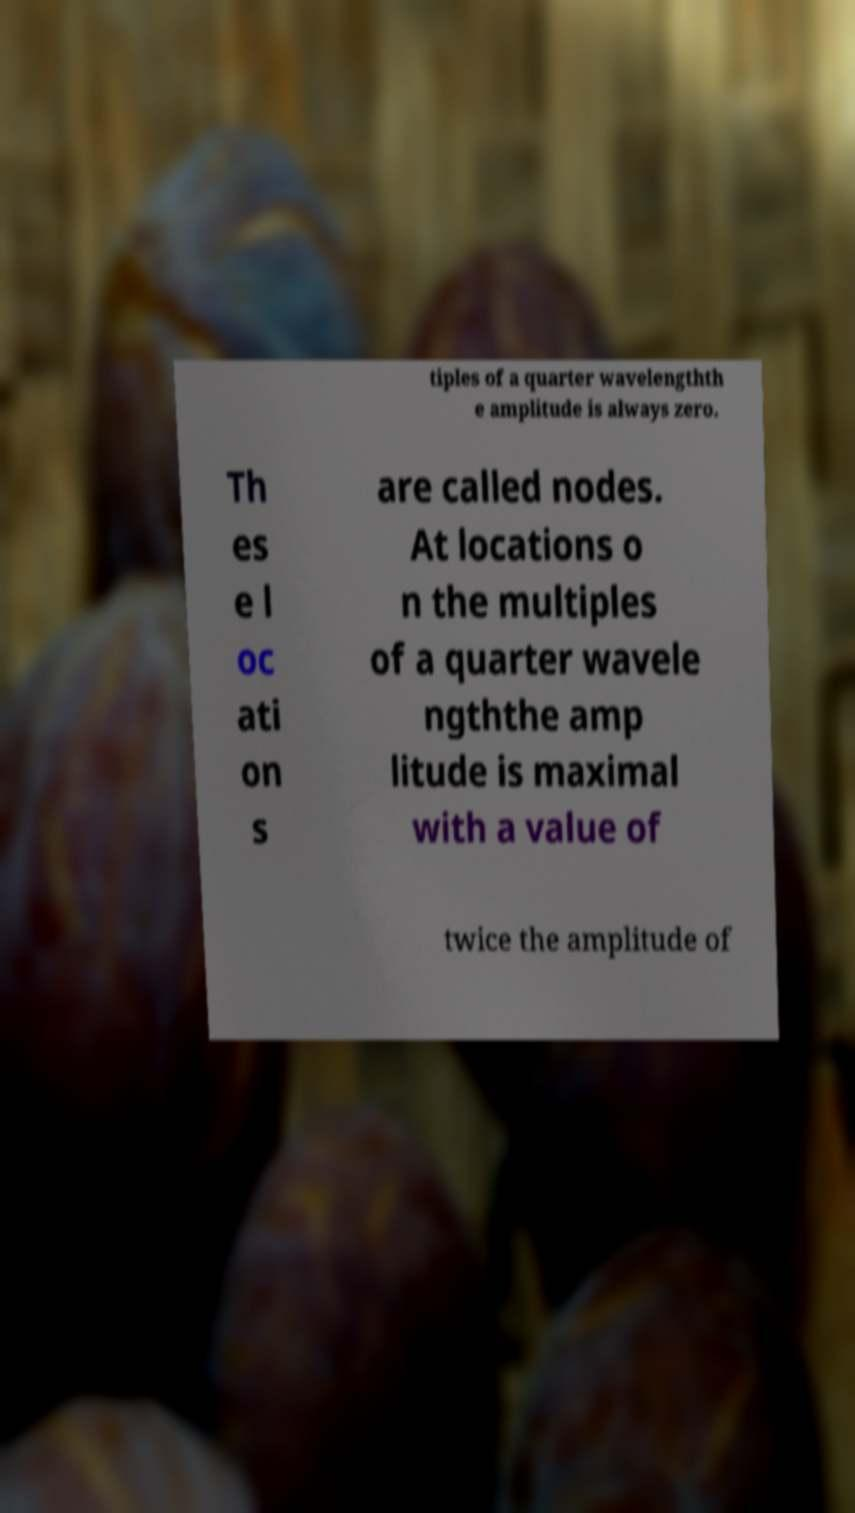What messages or text are displayed in this image? I need them in a readable, typed format. tiples of a quarter wavelengthth e amplitude is always zero. Th es e l oc ati on s are called nodes. At locations o n the multiples of a quarter wavele ngththe amp litude is maximal with a value of twice the amplitude of 